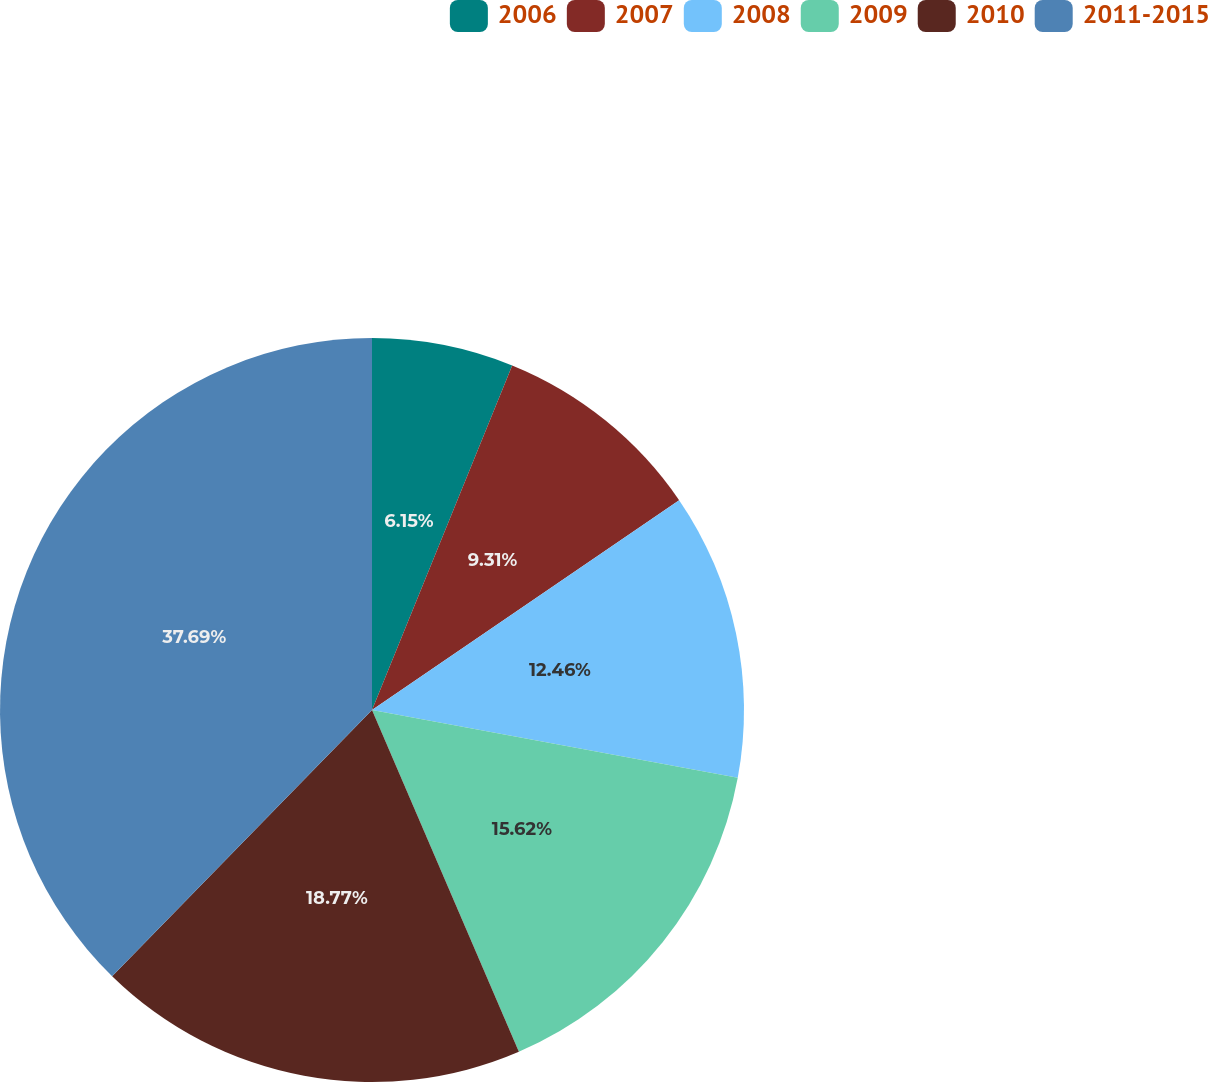<chart> <loc_0><loc_0><loc_500><loc_500><pie_chart><fcel>2006<fcel>2007<fcel>2008<fcel>2009<fcel>2010<fcel>2011-2015<nl><fcel>6.15%<fcel>9.31%<fcel>12.46%<fcel>15.62%<fcel>18.77%<fcel>37.69%<nl></chart> 